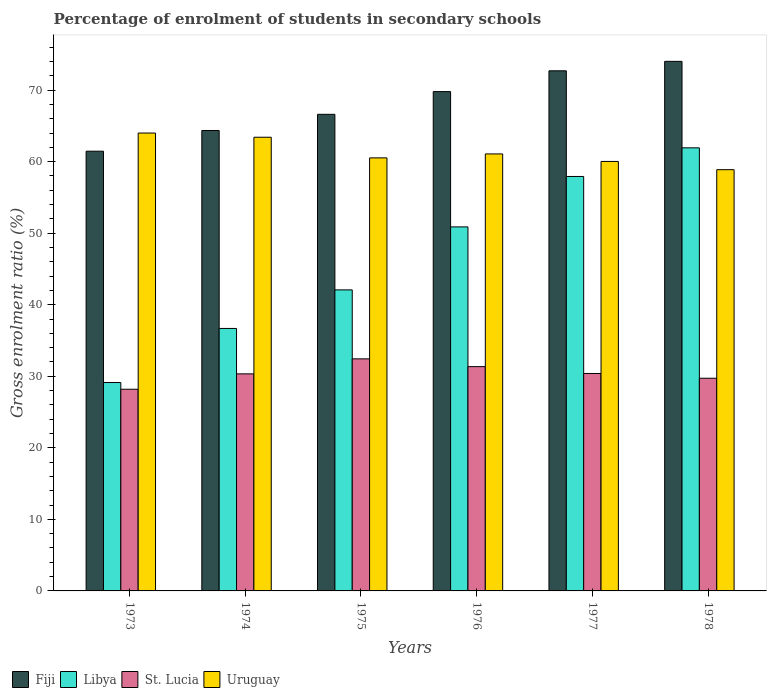How many different coloured bars are there?
Your response must be concise. 4. How many groups of bars are there?
Give a very brief answer. 6. Are the number of bars on each tick of the X-axis equal?
Offer a terse response. Yes. How many bars are there on the 1st tick from the left?
Ensure brevity in your answer.  4. What is the label of the 6th group of bars from the left?
Offer a terse response. 1978. In how many cases, is the number of bars for a given year not equal to the number of legend labels?
Your answer should be compact. 0. What is the percentage of students enrolled in secondary schools in Uruguay in 1974?
Provide a short and direct response. 63.41. Across all years, what is the maximum percentage of students enrolled in secondary schools in Fiji?
Give a very brief answer. 74.02. Across all years, what is the minimum percentage of students enrolled in secondary schools in Fiji?
Offer a terse response. 61.46. In which year was the percentage of students enrolled in secondary schools in St. Lucia maximum?
Your response must be concise. 1975. What is the total percentage of students enrolled in secondary schools in Uruguay in the graph?
Your answer should be very brief. 367.94. What is the difference between the percentage of students enrolled in secondary schools in St. Lucia in 1973 and that in 1977?
Give a very brief answer. -2.2. What is the difference between the percentage of students enrolled in secondary schools in Uruguay in 1975 and the percentage of students enrolled in secondary schools in Fiji in 1978?
Your response must be concise. -13.49. What is the average percentage of students enrolled in secondary schools in Uruguay per year?
Give a very brief answer. 61.32. In the year 1975, what is the difference between the percentage of students enrolled in secondary schools in Uruguay and percentage of students enrolled in secondary schools in Libya?
Your response must be concise. 18.45. What is the ratio of the percentage of students enrolled in secondary schools in Fiji in 1974 to that in 1978?
Your response must be concise. 0.87. Is the percentage of students enrolled in secondary schools in Libya in 1973 less than that in 1978?
Ensure brevity in your answer.  Yes. Is the difference between the percentage of students enrolled in secondary schools in Uruguay in 1975 and 1977 greater than the difference between the percentage of students enrolled in secondary schools in Libya in 1975 and 1977?
Give a very brief answer. Yes. What is the difference between the highest and the second highest percentage of students enrolled in secondary schools in Libya?
Ensure brevity in your answer.  4. What is the difference between the highest and the lowest percentage of students enrolled in secondary schools in Fiji?
Your response must be concise. 12.56. What does the 2nd bar from the left in 1975 represents?
Give a very brief answer. Libya. What does the 4th bar from the right in 1975 represents?
Make the answer very short. Fiji. How many bars are there?
Keep it short and to the point. 24. Are all the bars in the graph horizontal?
Provide a short and direct response. No. What is the difference between two consecutive major ticks on the Y-axis?
Offer a very short reply. 10. Where does the legend appear in the graph?
Offer a very short reply. Bottom left. How are the legend labels stacked?
Ensure brevity in your answer.  Horizontal. What is the title of the graph?
Offer a terse response. Percentage of enrolment of students in secondary schools. Does "Tonga" appear as one of the legend labels in the graph?
Your answer should be compact. No. What is the label or title of the X-axis?
Provide a succinct answer. Years. What is the label or title of the Y-axis?
Provide a succinct answer. Gross enrolment ratio (%). What is the Gross enrolment ratio (%) of Fiji in 1973?
Keep it short and to the point. 61.46. What is the Gross enrolment ratio (%) in Libya in 1973?
Your response must be concise. 29.13. What is the Gross enrolment ratio (%) in St. Lucia in 1973?
Offer a very short reply. 28.19. What is the Gross enrolment ratio (%) in Uruguay in 1973?
Your response must be concise. 64. What is the Gross enrolment ratio (%) of Fiji in 1974?
Offer a terse response. 64.36. What is the Gross enrolment ratio (%) of Libya in 1974?
Your answer should be very brief. 36.69. What is the Gross enrolment ratio (%) in St. Lucia in 1974?
Offer a very short reply. 30.34. What is the Gross enrolment ratio (%) in Uruguay in 1974?
Your response must be concise. 63.41. What is the Gross enrolment ratio (%) of Fiji in 1975?
Keep it short and to the point. 66.62. What is the Gross enrolment ratio (%) in Libya in 1975?
Provide a short and direct response. 42.08. What is the Gross enrolment ratio (%) of St. Lucia in 1975?
Ensure brevity in your answer.  32.44. What is the Gross enrolment ratio (%) of Uruguay in 1975?
Your answer should be very brief. 60.53. What is the Gross enrolment ratio (%) in Fiji in 1976?
Offer a very short reply. 69.79. What is the Gross enrolment ratio (%) in Libya in 1976?
Your response must be concise. 50.88. What is the Gross enrolment ratio (%) in St. Lucia in 1976?
Your response must be concise. 31.35. What is the Gross enrolment ratio (%) in Uruguay in 1976?
Your answer should be compact. 61.08. What is the Gross enrolment ratio (%) of Fiji in 1977?
Offer a terse response. 72.7. What is the Gross enrolment ratio (%) in Libya in 1977?
Make the answer very short. 57.93. What is the Gross enrolment ratio (%) of St. Lucia in 1977?
Your answer should be compact. 30.39. What is the Gross enrolment ratio (%) in Uruguay in 1977?
Provide a succinct answer. 60.03. What is the Gross enrolment ratio (%) in Fiji in 1978?
Offer a very short reply. 74.02. What is the Gross enrolment ratio (%) in Libya in 1978?
Keep it short and to the point. 61.93. What is the Gross enrolment ratio (%) of St. Lucia in 1978?
Your answer should be very brief. 29.73. What is the Gross enrolment ratio (%) of Uruguay in 1978?
Offer a very short reply. 58.88. Across all years, what is the maximum Gross enrolment ratio (%) in Fiji?
Give a very brief answer. 74.02. Across all years, what is the maximum Gross enrolment ratio (%) in Libya?
Make the answer very short. 61.93. Across all years, what is the maximum Gross enrolment ratio (%) of St. Lucia?
Give a very brief answer. 32.44. Across all years, what is the maximum Gross enrolment ratio (%) of Uruguay?
Offer a very short reply. 64. Across all years, what is the minimum Gross enrolment ratio (%) in Fiji?
Your answer should be compact. 61.46. Across all years, what is the minimum Gross enrolment ratio (%) of Libya?
Provide a short and direct response. 29.13. Across all years, what is the minimum Gross enrolment ratio (%) of St. Lucia?
Your answer should be compact. 28.19. Across all years, what is the minimum Gross enrolment ratio (%) in Uruguay?
Your response must be concise. 58.88. What is the total Gross enrolment ratio (%) of Fiji in the graph?
Keep it short and to the point. 408.95. What is the total Gross enrolment ratio (%) in Libya in the graph?
Provide a succinct answer. 278.64. What is the total Gross enrolment ratio (%) in St. Lucia in the graph?
Your answer should be very brief. 182.44. What is the total Gross enrolment ratio (%) in Uruguay in the graph?
Offer a terse response. 367.94. What is the difference between the Gross enrolment ratio (%) in Fiji in 1973 and that in 1974?
Provide a succinct answer. -2.89. What is the difference between the Gross enrolment ratio (%) in Libya in 1973 and that in 1974?
Ensure brevity in your answer.  -7.56. What is the difference between the Gross enrolment ratio (%) of St. Lucia in 1973 and that in 1974?
Offer a terse response. -2.15. What is the difference between the Gross enrolment ratio (%) in Uruguay in 1973 and that in 1974?
Give a very brief answer. 0.59. What is the difference between the Gross enrolment ratio (%) in Fiji in 1973 and that in 1975?
Make the answer very short. -5.15. What is the difference between the Gross enrolment ratio (%) in Libya in 1973 and that in 1975?
Make the answer very short. -12.95. What is the difference between the Gross enrolment ratio (%) in St. Lucia in 1973 and that in 1975?
Your response must be concise. -4.25. What is the difference between the Gross enrolment ratio (%) of Uruguay in 1973 and that in 1975?
Your answer should be compact. 3.47. What is the difference between the Gross enrolment ratio (%) in Fiji in 1973 and that in 1976?
Make the answer very short. -8.33. What is the difference between the Gross enrolment ratio (%) in Libya in 1973 and that in 1976?
Provide a succinct answer. -21.75. What is the difference between the Gross enrolment ratio (%) of St. Lucia in 1973 and that in 1976?
Keep it short and to the point. -3.16. What is the difference between the Gross enrolment ratio (%) of Uruguay in 1973 and that in 1976?
Keep it short and to the point. 2.92. What is the difference between the Gross enrolment ratio (%) in Fiji in 1973 and that in 1977?
Give a very brief answer. -11.24. What is the difference between the Gross enrolment ratio (%) of Libya in 1973 and that in 1977?
Offer a terse response. -28.8. What is the difference between the Gross enrolment ratio (%) in St. Lucia in 1973 and that in 1977?
Ensure brevity in your answer.  -2.2. What is the difference between the Gross enrolment ratio (%) in Uruguay in 1973 and that in 1977?
Ensure brevity in your answer.  3.97. What is the difference between the Gross enrolment ratio (%) of Fiji in 1973 and that in 1978?
Provide a succinct answer. -12.56. What is the difference between the Gross enrolment ratio (%) of Libya in 1973 and that in 1978?
Offer a very short reply. -32.8. What is the difference between the Gross enrolment ratio (%) in St. Lucia in 1973 and that in 1978?
Offer a very short reply. -1.54. What is the difference between the Gross enrolment ratio (%) in Uruguay in 1973 and that in 1978?
Ensure brevity in your answer.  5.12. What is the difference between the Gross enrolment ratio (%) of Fiji in 1974 and that in 1975?
Provide a succinct answer. -2.26. What is the difference between the Gross enrolment ratio (%) in Libya in 1974 and that in 1975?
Your response must be concise. -5.39. What is the difference between the Gross enrolment ratio (%) of St. Lucia in 1974 and that in 1975?
Keep it short and to the point. -2.1. What is the difference between the Gross enrolment ratio (%) of Uruguay in 1974 and that in 1975?
Ensure brevity in your answer.  2.88. What is the difference between the Gross enrolment ratio (%) of Fiji in 1974 and that in 1976?
Make the answer very short. -5.44. What is the difference between the Gross enrolment ratio (%) in Libya in 1974 and that in 1976?
Give a very brief answer. -14.19. What is the difference between the Gross enrolment ratio (%) in St. Lucia in 1974 and that in 1976?
Keep it short and to the point. -1.01. What is the difference between the Gross enrolment ratio (%) of Uruguay in 1974 and that in 1976?
Your answer should be compact. 2.33. What is the difference between the Gross enrolment ratio (%) of Fiji in 1974 and that in 1977?
Provide a short and direct response. -8.34. What is the difference between the Gross enrolment ratio (%) of Libya in 1974 and that in 1977?
Ensure brevity in your answer.  -21.24. What is the difference between the Gross enrolment ratio (%) in St. Lucia in 1974 and that in 1977?
Make the answer very short. -0.06. What is the difference between the Gross enrolment ratio (%) of Uruguay in 1974 and that in 1977?
Give a very brief answer. 3.38. What is the difference between the Gross enrolment ratio (%) in Fiji in 1974 and that in 1978?
Make the answer very short. -9.66. What is the difference between the Gross enrolment ratio (%) in Libya in 1974 and that in 1978?
Give a very brief answer. -25.24. What is the difference between the Gross enrolment ratio (%) in St. Lucia in 1974 and that in 1978?
Give a very brief answer. 0.61. What is the difference between the Gross enrolment ratio (%) in Uruguay in 1974 and that in 1978?
Keep it short and to the point. 4.53. What is the difference between the Gross enrolment ratio (%) in Fiji in 1975 and that in 1976?
Give a very brief answer. -3.18. What is the difference between the Gross enrolment ratio (%) of Libya in 1975 and that in 1976?
Ensure brevity in your answer.  -8.81. What is the difference between the Gross enrolment ratio (%) of St. Lucia in 1975 and that in 1976?
Your answer should be very brief. 1.09. What is the difference between the Gross enrolment ratio (%) in Uruguay in 1975 and that in 1976?
Your response must be concise. -0.55. What is the difference between the Gross enrolment ratio (%) of Fiji in 1975 and that in 1977?
Make the answer very short. -6.08. What is the difference between the Gross enrolment ratio (%) of Libya in 1975 and that in 1977?
Offer a very short reply. -15.85. What is the difference between the Gross enrolment ratio (%) in St. Lucia in 1975 and that in 1977?
Offer a terse response. 2.04. What is the difference between the Gross enrolment ratio (%) in Uruguay in 1975 and that in 1977?
Ensure brevity in your answer.  0.5. What is the difference between the Gross enrolment ratio (%) of Fiji in 1975 and that in 1978?
Make the answer very short. -7.4. What is the difference between the Gross enrolment ratio (%) of Libya in 1975 and that in 1978?
Your answer should be compact. -19.86. What is the difference between the Gross enrolment ratio (%) in St. Lucia in 1975 and that in 1978?
Keep it short and to the point. 2.71. What is the difference between the Gross enrolment ratio (%) in Uruguay in 1975 and that in 1978?
Make the answer very short. 1.65. What is the difference between the Gross enrolment ratio (%) in Fiji in 1976 and that in 1977?
Offer a very short reply. -2.91. What is the difference between the Gross enrolment ratio (%) in Libya in 1976 and that in 1977?
Provide a succinct answer. -7.05. What is the difference between the Gross enrolment ratio (%) of St. Lucia in 1976 and that in 1977?
Offer a very short reply. 0.96. What is the difference between the Gross enrolment ratio (%) in Uruguay in 1976 and that in 1977?
Your response must be concise. 1.05. What is the difference between the Gross enrolment ratio (%) of Fiji in 1976 and that in 1978?
Your answer should be very brief. -4.23. What is the difference between the Gross enrolment ratio (%) in Libya in 1976 and that in 1978?
Provide a short and direct response. -11.05. What is the difference between the Gross enrolment ratio (%) in St. Lucia in 1976 and that in 1978?
Your answer should be very brief. 1.62. What is the difference between the Gross enrolment ratio (%) in Uruguay in 1976 and that in 1978?
Offer a terse response. 2.2. What is the difference between the Gross enrolment ratio (%) in Fiji in 1977 and that in 1978?
Provide a succinct answer. -1.32. What is the difference between the Gross enrolment ratio (%) in Libya in 1977 and that in 1978?
Your answer should be compact. -4. What is the difference between the Gross enrolment ratio (%) in St. Lucia in 1977 and that in 1978?
Make the answer very short. 0.67. What is the difference between the Gross enrolment ratio (%) in Uruguay in 1977 and that in 1978?
Your response must be concise. 1.15. What is the difference between the Gross enrolment ratio (%) of Fiji in 1973 and the Gross enrolment ratio (%) of Libya in 1974?
Ensure brevity in your answer.  24.78. What is the difference between the Gross enrolment ratio (%) in Fiji in 1973 and the Gross enrolment ratio (%) in St. Lucia in 1974?
Your answer should be very brief. 31.13. What is the difference between the Gross enrolment ratio (%) in Fiji in 1973 and the Gross enrolment ratio (%) in Uruguay in 1974?
Ensure brevity in your answer.  -1.95. What is the difference between the Gross enrolment ratio (%) of Libya in 1973 and the Gross enrolment ratio (%) of St. Lucia in 1974?
Your response must be concise. -1.21. What is the difference between the Gross enrolment ratio (%) in Libya in 1973 and the Gross enrolment ratio (%) in Uruguay in 1974?
Provide a short and direct response. -34.29. What is the difference between the Gross enrolment ratio (%) in St. Lucia in 1973 and the Gross enrolment ratio (%) in Uruguay in 1974?
Provide a short and direct response. -35.22. What is the difference between the Gross enrolment ratio (%) in Fiji in 1973 and the Gross enrolment ratio (%) in Libya in 1975?
Your response must be concise. 19.39. What is the difference between the Gross enrolment ratio (%) of Fiji in 1973 and the Gross enrolment ratio (%) of St. Lucia in 1975?
Your response must be concise. 29.03. What is the difference between the Gross enrolment ratio (%) in Fiji in 1973 and the Gross enrolment ratio (%) in Uruguay in 1975?
Give a very brief answer. 0.93. What is the difference between the Gross enrolment ratio (%) of Libya in 1973 and the Gross enrolment ratio (%) of St. Lucia in 1975?
Offer a terse response. -3.31. What is the difference between the Gross enrolment ratio (%) of Libya in 1973 and the Gross enrolment ratio (%) of Uruguay in 1975?
Offer a very short reply. -31.4. What is the difference between the Gross enrolment ratio (%) in St. Lucia in 1973 and the Gross enrolment ratio (%) in Uruguay in 1975?
Ensure brevity in your answer.  -32.34. What is the difference between the Gross enrolment ratio (%) of Fiji in 1973 and the Gross enrolment ratio (%) of Libya in 1976?
Offer a very short reply. 10.58. What is the difference between the Gross enrolment ratio (%) of Fiji in 1973 and the Gross enrolment ratio (%) of St. Lucia in 1976?
Your response must be concise. 30.11. What is the difference between the Gross enrolment ratio (%) of Fiji in 1973 and the Gross enrolment ratio (%) of Uruguay in 1976?
Give a very brief answer. 0.38. What is the difference between the Gross enrolment ratio (%) of Libya in 1973 and the Gross enrolment ratio (%) of St. Lucia in 1976?
Ensure brevity in your answer.  -2.22. What is the difference between the Gross enrolment ratio (%) in Libya in 1973 and the Gross enrolment ratio (%) in Uruguay in 1976?
Ensure brevity in your answer.  -31.95. What is the difference between the Gross enrolment ratio (%) of St. Lucia in 1973 and the Gross enrolment ratio (%) of Uruguay in 1976?
Your response must be concise. -32.89. What is the difference between the Gross enrolment ratio (%) of Fiji in 1973 and the Gross enrolment ratio (%) of Libya in 1977?
Your answer should be very brief. 3.54. What is the difference between the Gross enrolment ratio (%) in Fiji in 1973 and the Gross enrolment ratio (%) in St. Lucia in 1977?
Give a very brief answer. 31.07. What is the difference between the Gross enrolment ratio (%) of Fiji in 1973 and the Gross enrolment ratio (%) of Uruguay in 1977?
Make the answer very short. 1.43. What is the difference between the Gross enrolment ratio (%) of Libya in 1973 and the Gross enrolment ratio (%) of St. Lucia in 1977?
Make the answer very short. -1.27. What is the difference between the Gross enrolment ratio (%) in Libya in 1973 and the Gross enrolment ratio (%) in Uruguay in 1977?
Keep it short and to the point. -30.9. What is the difference between the Gross enrolment ratio (%) of St. Lucia in 1973 and the Gross enrolment ratio (%) of Uruguay in 1977?
Offer a very short reply. -31.84. What is the difference between the Gross enrolment ratio (%) in Fiji in 1973 and the Gross enrolment ratio (%) in Libya in 1978?
Offer a terse response. -0.47. What is the difference between the Gross enrolment ratio (%) of Fiji in 1973 and the Gross enrolment ratio (%) of St. Lucia in 1978?
Your answer should be compact. 31.74. What is the difference between the Gross enrolment ratio (%) in Fiji in 1973 and the Gross enrolment ratio (%) in Uruguay in 1978?
Offer a terse response. 2.58. What is the difference between the Gross enrolment ratio (%) in Libya in 1973 and the Gross enrolment ratio (%) in St. Lucia in 1978?
Offer a terse response. -0.6. What is the difference between the Gross enrolment ratio (%) in Libya in 1973 and the Gross enrolment ratio (%) in Uruguay in 1978?
Make the answer very short. -29.75. What is the difference between the Gross enrolment ratio (%) in St. Lucia in 1973 and the Gross enrolment ratio (%) in Uruguay in 1978?
Offer a very short reply. -30.69. What is the difference between the Gross enrolment ratio (%) of Fiji in 1974 and the Gross enrolment ratio (%) of Libya in 1975?
Your answer should be compact. 22.28. What is the difference between the Gross enrolment ratio (%) of Fiji in 1974 and the Gross enrolment ratio (%) of St. Lucia in 1975?
Your answer should be very brief. 31.92. What is the difference between the Gross enrolment ratio (%) of Fiji in 1974 and the Gross enrolment ratio (%) of Uruguay in 1975?
Provide a short and direct response. 3.83. What is the difference between the Gross enrolment ratio (%) of Libya in 1974 and the Gross enrolment ratio (%) of St. Lucia in 1975?
Your response must be concise. 4.25. What is the difference between the Gross enrolment ratio (%) of Libya in 1974 and the Gross enrolment ratio (%) of Uruguay in 1975?
Provide a short and direct response. -23.84. What is the difference between the Gross enrolment ratio (%) in St. Lucia in 1974 and the Gross enrolment ratio (%) in Uruguay in 1975?
Your answer should be very brief. -30.19. What is the difference between the Gross enrolment ratio (%) in Fiji in 1974 and the Gross enrolment ratio (%) in Libya in 1976?
Provide a short and direct response. 13.47. What is the difference between the Gross enrolment ratio (%) of Fiji in 1974 and the Gross enrolment ratio (%) of St. Lucia in 1976?
Your answer should be compact. 33.01. What is the difference between the Gross enrolment ratio (%) of Fiji in 1974 and the Gross enrolment ratio (%) of Uruguay in 1976?
Keep it short and to the point. 3.28. What is the difference between the Gross enrolment ratio (%) in Libya in 1974 and the Gross enrolment ratio (%) in St. Lucia in 1976?
Provide a short and direct response. 5.34. What is the difference between the Gross enrolment ratio (%) in Libya in 1974 and the Gross enrolment ratio (%) in Uruguay in 1976?
Your answer should be compact. -24.39. What is the difference between the Gross enrolment ratio (%) of St. Lucia in 1974 and the Gross enrolment ratio (%) of Uruguay in 1976?
Give a very brief answer. -30.74. What is the difference between the Gross enrolment ratio (%) of Fiji in 1974 and the Gross enrolment ratio (%) of Libya in 1977?
Make the answer very short. 6.43. What is the difference between the Gross enrolment ratio (%) in Fiji in 1974 and the Gross enrolment ratio (%) in St. Lucia in 1977?
Make the answer very short. 33.96. What is the difference between the Gross enrolment ratio (%) of Fiji in 1974 and the Gross enrolment ratio (%) of Uruguay in 1977?
Offer a terse response. 4.33. What is the difference between the Gross enrolment ratio (%) in Libya in 1974 and the Gross enrolment ratio (%) in St. Lucia in 1977?
Your response must be concise. 6.3. What is the difference between the Gross enrolment ratio (%) of Libya in 1974 and the Gross enrolment ratio (%) of Uruguay in 1977?
Your answer should be very brief. -23.34. What is the difference between the Gross enrolment ratio (%) of St. Lucia in 1974 and the Gross enrolment ratio (%) of Uruguay in 1977?
Offer a very short reply. -29.69. What is the difference between the Gross enrolment ratio (%) in Fiji in 1974 and the Gross enrolment ratio (%) in Libya in 1978?
Provide a succinct answer. 2.42. What is the difference between the Gross enrolment ratio (%) of Fiji in 1974 and the Gross enrolment ratio (%) of St. Lucia in 1978?
Keep it short and to the point. 34.63. What is the difference between the Gross enrolment ratio (%) in Fiji in 1974 and the Gross enrolment ratio (%) in Uruguay in 1978?
Offer a very short reply. 5.48. What is the difference between the Gross enrolment ratio (%) of Libya in 1974 and the Gross enrolment ratio (%) of St. Lucia in 1978?
Make the answer very short. 6.96. What is the difference between the Gross enrolment ratio (%) in Libya in 1974 and the Gross enrolment ratio (%) in Uruguay in 1978?
Make the answer very short. -22.19. What is the difference between the Gross enrolment ratio (%) in St. Lucia in 1974 and the Gross enrolment ratio (%) in Uruguay in 1978?
Your response must be concise. -28.54. What is the difference between the Gross enrolment ratio (%) of Fiji in 1975 and the Gross enrolment ratio (%) of Libya in 1976?
Offer a terse response. 15.73. What is the difference between the Gross enrolment ratio (%) of Fiji in 1975 and the Gross enrolment ratio (%) of St. Lucia in 1976?
Provide a short and direct response. 35.27. What is the difference between the Gross enrolment ratio (%) of Fiji in 1975 and the Gross enrolment ratio (%) of Uruguay in 1976?
Make the answer very short. 5.54. What is the difference between the Gross enrolment ratio (%) in Libya in 1975 and the Gross enrolment ratio (%) in St. Lucia in 1976?
Your answer should be very brief. 10.73. What is the difference between the Gross enrolment ratio (%) of Libya in 1975 and the Gross enrolment ratio (%) of Uruguay in 1976?
Provide a succinct answer. -19. What is the difference between the Gross enrolment ratio (%) in St. Lucia in 1975 and the Gross enrolment ratio (%) in Uruguay in 1976?
Your answer should be compact. -28.64. What is the difference between the Gross enrolment ratio (%) of Fiji in 1975 and the Gross enrolment ratio (%) of Libya in 1977?
Offer a very short reply. 8.69. What is the difference between the Gross enrolment ratio (%) in Fiji in 1975 and the Gross enrolment ratio (%) in St. Lucia in 1977?
Keep it short and to the point. 36.22. What is the difference between the Gross enrolment ratio (%) of Fiji in 1975 and the Gross enrolment ratio (%) of Uruguay in 1977?
Make the answer very short. 6.59. What is the difference between the Gross enrolment ratio (%) in Libya in 1975 and the Gross enrolment ratio (%) in St. Lucia in 1977?
Your answer should be compact. 11.68. What is the difference between the Gross enrolment ratio (%) in Libya in 1975 and the Gross enrolment ratio (%) in Uruguay in 1977?
Give a very brief answer. -17.95. What is the difference between the Gross enrolment ratio (%) of St. Lucia in 1975 and the Gross enrolment ratio (%) of Uruguay in 1977?
Your answer should be very brief. -27.59. What is the difference between the Gross enrolment ratio (%) of Fiji in 1975 and the Gross enrolment ratio (%) of Libya in 1978?
Your answer should be compact. 4.68. What is the difference between the Gross enrolment ratio (%) in Fiji in 1975 and the Gross enrolment ratio (%) in St. Lucia in 1978?
Ensure brevity in your answer.  36.89. What is the difference between the Gross enrolment ratio (%) in Fiji in 1975 and the Gross enrolment ratio (%) in Uruguay in 1978?
Keep it short and to the point. 7.74. What is the difference between the Gross enrolment ratio (%) in Libya in 1975 and the Gross enrolment ratio (%) in St. Lucia in 1978?
Provide a short and direct response. 12.35. What is the difference between the Gross enrolment ratio (%) of Libya in 1975 and the Gross enrolment ratio (%) of Uruguay in 1978?
Your response must be concise. -16.8. What is the difference between the Gross enrolment ratio (%) of St. Lucia in 1975 and the Gross enrolment ratio (%) of Uruguay in 1978?
Provide a short and direct response. -26.44. What is the difference between the Gross enrolment ratio (%) of Fiji in 1976 and the Gross enrolment ratio (%) of Libya in 1977?
Give a very brief answer. 11.87. What is the difference between the Gross enrolment ratio (%) in Fiji in 1976 and the Gross enrolment ratio (%) in St. Lucia in 1977?
Your answer should be compact. 39.4. What is the difference between the Gross enrolment ratio (%) in Fiji in 1976 and the Gross enrolment ratio (%) in Uruguay in 1977?
Offer a very short reply. 9.76. What is the difference between the Gross enrolment ratio (%) of Libya in 1976 and the Gross enrolment ratio (%) of St. Lucia in 1977?
Give a very brief answer. 20.49. What is the difference between the Gross enrolment ratio (%) in Libya in 1976 and the Gross enrolment ratio (%) in Uruguay in 1977?
Ensure brevity in your answer.  -9.15. What is the difference between the Gross enrolment ratio (%) of St. Lucia in 1976 and the Gross enrolment ratio (%) of Uruguay in 1977?
Provide a succinct answer. -28.68. What is the difference between the Gross enrolment ratio (%) in Fiji in 1976 and the Gross enrolment ratio (%) in Libya in 1978?
Your response must be concise. 7.86. What is the difference between the Gross enrolment ratio (%) of Fiji in 1976 and the Gross enrolment ratio (%) of St. Lucia in 1978?
Give a very brief answer. 40.07. What is the difference between the Gross enrolment ratio (%) of Fiji in 1976 and the Gross enrolment ratio (%) of Uruguay in 1978?
Provide a short and direct response. 10.91. What is the difference between the Gross enrolment ratio (%) of Libya in 1976 and the Gross enrolment ratio (%) of St. Lucia in 1978?
Make the answer very short. 21.15. What is the difference between the Gross enrolment ratio (%) of Libya in 1976 and the Gross enrolment ratio (%) of Uruguay in 1978?
Make the answer very short. -8. What is the difference between the Gross enrolment ratio (%) in St. Lucia in 1976 and the Gross enrolment ratio (%) in Uruguay in 1978?
Your answer should be compact. -27.53. What is the difference between the Gross enrolment ratio (%) of Fiji in 1977 and the Gross enrolment ratio (%) of Libya in 1978?
Ensure brevity in your answer.  10.77. What is the difference between the Gross enrolment ratio (%) in Fiji in 1977 and the Gross enrolment ratio (%) in St. Lucia in 1978?
Make the answer very short. 42.97. What is the difference between the Gross enrolment ratio (%) in Fiji in 1977 and the Gross enrolment ratio (%) in Uruguay in 1978?
Your answer should be compact. 13.82. What is the difference between the Gross enrolment ratio (%) in Libya in 1977 and the Gross enrolment ratio (%) in St. Lucia in 1978?
Give a very brief answer. 28.2. What is the difference between the Gross enrolment ratio (%) in Libya in 1977 and the Gross enrolment ratio (%) in Uruguay in 1978?
Your response must be concise. -0.95. What is the difference between the Gross enrolment ratio (%) of St. Lucia in 1977 and the Gross enrolment ratio (%) of Uruguay in 1978?
Keep it short and to the point. -28.49. What is the average Gross enrolment ratio (%) of Fiji per year?
Provide a succinct answer. 68.16. What is the average Gross enrolment ratio (%) of Libya per year?
Keep it short and to the point. 46.44. What is the average Gross enrolment ratio (%) of St. Lucia per year?
Provide a succinct answer. 30.41. What is the average Gross enrolment ratio (%) in Uruguay per year?
Make the answer very short. 61.32. In the year 1973, what is the difference between the Gross enrolment ratio (%) in Fiji and Gross enrolment ratio (%) in Libya?
Make the answer very short. 32.34. In the year 1973, what is the difference between the Gross enrolment ratio (%) of Fiji and Gross enrolment ratio (%) of St. Lucia?
Your answer should be very brief. 33.27. In the year 1973, what is the difference between the Gross enrolment ratio (%) of Fiji and Gross enrolment ratio (%) of Uruguay?
Make the answer very short. -2.54. In the year 1973, what is the difference between the Gross enrolment ratio (%) of Libya and Gross enrolment ratio (%) of St. Lucia?
Give a very brief answer. 0.94. In the year 1973, what is the difference between the Gross enrolment ratio (%) in Libya and Gross enrolment ratio (%) in Uruguay?
Your answer should be very brief. -34.87. In the year 1973, what is the difference between the Gross enrolment ratio (%) in St. Lucia and Gross enrolment ratio (%) in Uruguay?
Give a very brief answer. -35.81. In the year 1974, what is the difference between the Gross enrolment ratio (%) of Fiji and Gross enrolment ratio (%) of Libya?
Give a very brief answer. 27.67. In the year 1974, what is the difference between the Gross enrolment ratio (%) in Fiji and Gross enrolment ratio (%) in St. Lucia?
Provide a succinct answer. 34.02. In the year 1974, what is the difference between the Gross enrolment ratio (%) in Fiji and Gross enrolment ratio (%) in Uruguay?
Your response must be concise. 0.94. In the year 1974, what is the difference between the Gross enrolment ratio (%) in Libya and Gross enrolment ratio (%) in St. Lucia?
Your response must be concise. 6.35. In the year 1974, what is the difference between the Gross enrolment ratio (%) of Libya and Gross enrolment ratio (%) of Uruguay?
Give a very brief answer. -26.73. In the year 1974, what is the difference between the Gross enrolment ratio (%) of St. Lucia and Gross enrolment ratio (%) of Uruguay?
Give a very brief answer. -33.08. In the year 1975, what is the difference between the Gross enrolment ratio (%) of Fiji and Gross enrolment ratio (%) of Libya?
Your response must be concise. 24.54. In the year 1975, what is the difference between the Gross enrolment ratio (%) of Fiji and Gross enrolment ratio (%) of St. Lucia?
Your response must be concise. 34.18. In the year 1975, what is the difference between the Gross enrolment ratio (%) of Fiji and Gross enrolment ratio (%) of Uruguay?
Provide a short and direct response. 6.09. In the year 1975, what is the difference between the Gross enrolment ratio (%) of Libya and Gross enrolment ratio (%) of St. Lucia?
Your response must be concise. 9.64. In the year 1975, what is the difference between the Gross enrolment ratio (%) of Libya and Gross enrolment ratio (%) of Uruguay?
Your answer should be compact. -18.45. In the year 1975, what is the difference between the Gross enrolment ratio (%) in St. Lucia and Gross enrolment ratio (%) in Uruguay?
Your response must be concise. -28.09. In the year 1976, what is the difference between the Gross enrolment ratio (%) in Fiji and Gross enrolment ratio (%) in Libya?
Offer a terse response. 18.91. In the year 1976, what is the difference between the Gross enrolment ratio (%) of Fiji and Gross enrolment ratio (%) of St. Lucia?
Your answer should be very brief. 38.44. In the year 1976, what is the difference between the Gross enrolment ratio (%) of Fiji and Gross enrolment ratio (%) of Uruguay?
Your answer should be very brief. 8.71. In the year 1976, what is the difference between the Gross enrolment ratio (%) of Libya and Gross enrolment ratio (%) of St. Lucia?
Ensure brevity in your answer.  19.53. In the year 1976, what is the difference between the Gross enrolment ratio (%) of Libya and Gross enrolment ratio (%) of Uruguay?
Give a very brief answer. -10.2. In the year 1976, what is the difference between the Gross enrolment ratio (%) in St. Lucia and Gross enrolment ratio (%) in Uruguay?
Keep it short and to the point. -29.73. In the year 1977, what is the difference between the Gross enrolment ratio (%) in Fiji and Gross enrolment ratio (%) in Libya?
Keep it short and to the point. 14.77. In the year 1977, what is the difference between the Gross enrolment ratio (%) of Fiji and Gross enrolment ratio (%) of St. Lucia?
Your response must be concise. 42.31. In the year 1977, what is the difference between the Gross enrolment ratio (%) in Fiji and Gross enrolment ratio (%) in Uruguay?
Provide a succinct answer. 12.67. In the year 1977, what is the difference between the Gross enrolment ratio (%) in Libya and Gross enrolment ratio (%) in St. Lucia?
Your response must be concise. 27.54. In the year 1977, what is the difference between the Gross enrolment ratio (%) in Libya and Gross enrolment ratio (%) in Uruguay?
Your answer should be compact. -2.1. In the year 1977, what is the difference between the Gross enrolment ratio (%) of St. Lucia and Gross enrolment ratio (%) of Uruguay?
Keep it short and to the point. -29.64. In the year 1978, what is the difference between the Gross enrolment ratio (%) of Fiji and Gross enrolment ratio (%) of Libya?
Offer a very short reply. 12.09. In the year 1978, what is the difference between the Gross enrolment ratio (%) of Fiji and Gross enrolment ratio (%) of St. Lucia?
Make the answer very short. 44.29. In the year 1978, what is the difference between the Gross enrolment ratio (%) of Fiji and Gross enrolment ratio (%) of Uruguay?
Your answer should be compact. 15.14. In the year 1978, what is the difference between the Gross enrolment ratio (%) of Libya and Gross enrolment ratio (%) of St. Lucia?
Keep it short and to the point. 32.2. In the year 1978, what is the difference between the Gross enrolment ratio (%) in Libya and Gross enrolment ratio (%) in Uruguay?
Offer a very short reply. 3.05. In the year 1978, what is the difference between the Gross enrolment ratio (%) in St. Lucia and Gross enrolment ratio (%) in Uruguay?
Ensure brevity in your answer.  -29.15. What is the ratio of the Gross enrolment ratio (%) of Fiji in 1973 to that in 1974?
Provide a succinct answer. 0.96. What is the ratio of the Gross enrolment ratio (%) of Libya in 1973 to that in 1974?
Keep it short and to the point. 0.79. What is the ratio of the Gross enrolment ratio (%) of St. Lucia in 1973 to that in 1974?
Your answer should be compact. 0.93. What is the ratio of the Gross enrolment ratio (%) of Uruguay in 1973 to that in 1974?
Your answer should be very brief. 1.01. What is the ratio of the Gross enrolment ratio (%) in Fiji in 1973 to that in 1975?
Ensure brevity in your answer.  0.92. What is the ratio of the Gross enrolment ratio (%) in Libya in 1973 to that in 1975?
Provide a succinct answer. 0.69. What is the ratio of the Gross enrolment ratio (%) in St. Lucia in 1973 to that in 1975?
Your response must be concise. 0.87. What is the ratio of the Gross enrolment ratio (%) of Uruguay in 1973 to that in 1975?
Ensure brevity in your answer.  1.06. What is the ratio of the Gross enrolment ratio (%) in Fiji in 1973 to that in 1976?
Keep it short and to the point. 0.88. What is the ratio of the Gross enrolment ratio (%) of Libya in 1973 to that in 1976?
Ensure brevity in your answer.  0.57. What is the ratio of the Gross enrolment ratio (%) of St. Lucia in 1973 to that in 1976?
Give a very brief answer. 0.9. What is the ratio of the Gross enrolment ratio (%) of Uruguay in 1973 to that in 1976?
Keep it short and to the point. 1.05. What is the ratio of the Gross enrolment ratio (%) of Fiji in 1973 to that in 1977?
Offer a very short reply. 0.85. What is the ratio of the Gross enrolment ratio (%) in Libya in 1973 to that in 1977?
Offer a terse response. 0.5. What is the ratio of the Gross enrolment ratio (%) in St. Lucia in 1973 to that in 1977?
Provide a short and direct response. 0.93. What is the ratio of the Gross enrolment ratio (%) of Uruguay in 1973 to that in 1977?
Your response must be concise. 1.07. What is the ratio of the Gross enrolment ratio (%) of Fiji in 1973 to that in 1978?
Give a very brief answer. 0.83. What is the ratio of the Gross enrolment ratio (%) in Libya in 1973 to that in 1978?
Your answer should be compact. 0.47. What is the ratio of the Gross enrolment ratio (%) in St. Lucia in 1973 to that in 1978?
Keep it short and to the point. 0.95. What is the ratio of the Gross enrolment ratio (%) of Uruguay in 1973 to that in 1978?
Offer a very short reply. 1.09. What is the ratio of the Gross enrolment ratio (%) in Fiji in 1974 to that in 1975?
Ensure brevity in your answer.  0.97. What is the ratio of the Gross enrolment ratio (%) of Libya in 1974 to that in 1975?
Keep it short and to the point. 0.87. What is the ratio of the Gross enrolment ratio (%) in St. Lucia in 1974 to that in 1975?
Offer a very short reply. 0.94. What is the ratio of the Gross enrolment ratio (%) of Uruguay in 1974 to that in 1975?
Your answer should be very brief. 1.05. What is the ratio of the Gross enrolment ratio (%) in Fiji in 1974 to that in 1976?
Ensure brevity in your answer.  0.92. What is the ratio of the Gross enrolment ratio (%) of Libya in 1974 to that in 1976?
Provide a short and direct response. 0.72. What is the ratio of the Gross enrolment ratio (%) of St. Lucia in 1974 to that in 1976?
Your answer should be compact. 0.97. What is the ratio of the Gross enrolment ratio (%) in Uruguay in 1974 to that in 1976?
Make the answer very short. 1.04. What is the ratio of the Gross enrolment ratio (%) in Fiji in 1974 to that in 1977?
Provide a short and direct response. 0.89. What is the ratio of the Gross enrolment ratio (%) in Libya in 1974 to that in 1977?
Ensure brevity in your answer.  0.63. What is the ratio of the Gross enrolment ratio (%) in St. Lucia in 1974 to that in 1977?
Your answer should be very brief. 1. What is the ratio of the Gross enrolment ratio (%) of Uruguay in 1974 to that in 1977?
Offer a terse response. 1.06. What is the ratio of the Gross enrolment ratio (%) of Fiji in 1974 to that in 1978?
Keep it short and to the point. 0.87. What is the ratio of the Gross enrolment ratio (%) of Libya in 1974 to that in 1978?
Your answer should be compact. 0.59. What is the ratio of the Gross enrolment ratio (%) in St. Lucia in 1974 to that in 1978?
Provide a succinct answer. 1.02. What is the ratio of the Gross enrolment ratio (%) of Uruguay in 1974 to that in 1978?
Make the answer very short. 1.08. What is the ratio of the Gross enrolment ratio (%) of Fiji in 1975 to that in 1976?
Your answer should be very brief. 0.95. What is the ratio of the Gross enrolment ratio (%) of Libya in 1975 to that in 1976?
Your response must be concise. 0.83. What is the ratio of the Gross enrolment ratio (%) in St. Lucia in 1975 to that in 1976?
Offer a very short reply. 1.03. What is the ratio of the Gross enrolment ratio (%) of Fiji in 1975 to that in 1977?
Your answer should be very brief. 0.92. What is the ratio of the Gross enrolment ratio (%) in Libya in 1975 to that in 1977?
Offer a terse response. 0.73. What is the ratio of the Gross enrolment ratio (%) in St. Lucia in 1975 to that in 1977?
Offer a very short reply. 1.07. What is the ratio of the Gross enrolment ratio (%) of Uruguay in 1975 to that in 1977?
Offer a very short reply. 1.01. What is the ratio of the Gross enrolment ratio (%) of Libya in 1975 to that in 1978?
Offer a terse response. 0.68. What is the ratio of the Gross enrolment ratio (%) of St. Lucia in 1975 to that in 1978?
Make the answer very short. 1.09. What is the ratio of the Gross enrolment ratio (%) in Uruguay in 1975 to that in 1978?
Offer a terse response. 1.03. What is the ratio of the Gross enrolment ratio (%) in Fiji in 1976 to that in 1977?
Provide a short and direct response. 0.96. What is the ratio of the Gross enrolment ratio (%) in Libya in 1976 to that in 1977?
Your response must be concise. 0.88. What is the ratio of the Gross enrolment ratio (%) of St. Lucia in 1976 to that in 1977?
Keep it short and to the point. 1.03. What is the ratio of the Gross enrolment ratio (%) in Uruguay in 1976 to that in 1977?
Keep it short and to the point. 1.02. What is the ratio of the Gross enrolment ratio (%) in Fiji in 1976 to that in 1978?
Give a very brief answer. 0.94. What is the ratio of the Gross enrolment ratio (%) in Libya in 1976 to that in 1978?
Keep it short and to the point. 0.82. What is the ratio of the Gross enrolment ratio (%) of St. Lucia in 1976 to that in 1978?
Provide a succinct answer. 1.05. What is the ratio of the Gross enrolment ratio (%) of Uruguay in 1976 to that in 1978?
Offer a very short reply. 1.04. What is the ratio of the Gross enrolment ratio (%) in Fiji in 1977 to that in 1978?
Your answer should be very brief. 0.98. What is the ratio of the Gross enrolment ratio (%) in Libya in 1977 to that in 1978?
Make the answer very short. 0.94. What is the ratio of the Gross enrolment ratio (%) of St. Lucia in 1977 to that in 1978?
Provide a short and direct response. 1.02. What is the ratio of the Gross enrolment ratio (%) of Uruguay in 1977 to that in 1978?
Offer a terse response. 1.02. What is the difference between the highest and the second highest Gross enrolment ratio (%) in Fiji?
Make the answer very short. 1.32. What is the difference between the highest and the second highest Gross enrolment ratio (%) of Libya?
Your response must be concise. 4. What is the difference between the highest and the second highest Gross enrolment ratio (%) of St. Lucia?
Your response must be concise. 1.09. What is the difference between the highest and the second highest Gross enrolment ratio (%) in Uruguay?
Offer a very short reply. 0.59. What is the difference between the highest and the lowest Gross enrolment ratio (%) in Fiji?
Make the answer very short. 12.56. What is the difference between the highest and the lowest Gross enrolment ratio (%) in Libya?
Make the answer very short. 32.8. What is the difference between the highest and the lowest Gross enrolment ratio (%) in St. Lucia?
Give a very brief answer. 4.25. What is the difference between the highest and the lowest Gross enrolment ratio (%) of Uruguay?
Ensure brevity in your answer.  5.12. 